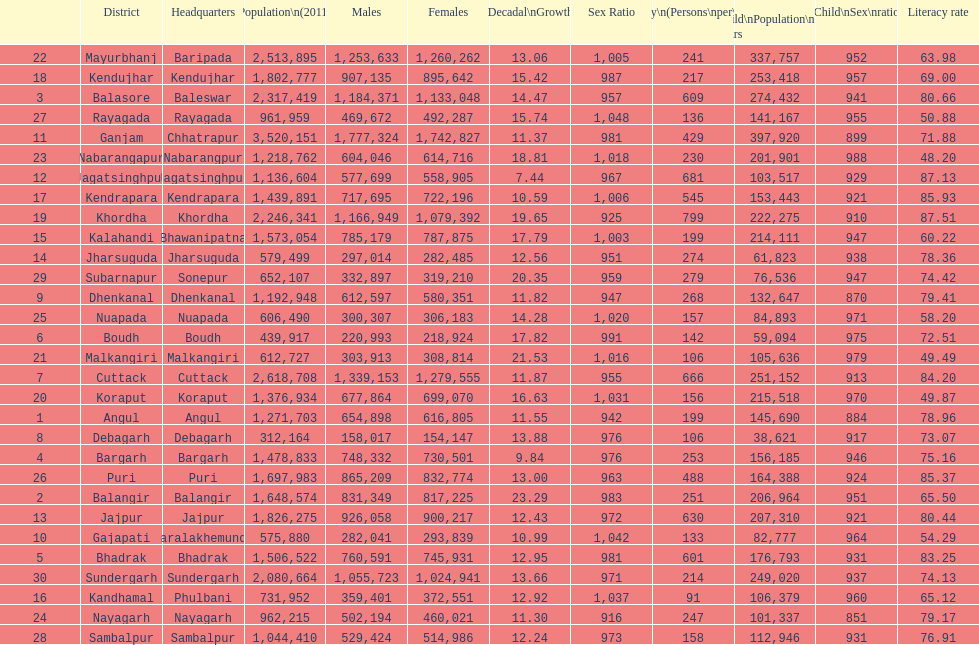What is the number of districts with percentage decadal growth above 15% 10. 